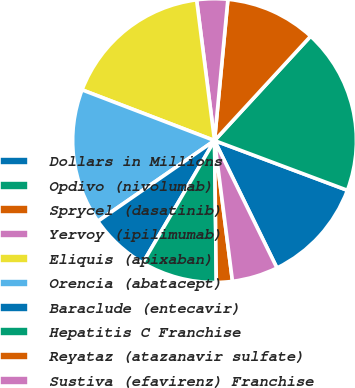Convert chart to OTSL. <chart><loc_0><loc_0><loc_500><loc_500><pie_chart><fcel>Dollars in Millions<fcel>Opdivo (nivolumab)<fcel>Sprycel (dasatinib)<fcel>Yervoy (ipilimumab)<fcel>Eliquis (apixaban)<fcel>Orencia (abatacept)<fcel>Baraclude (entecavir)<fcel>Hepatitis C Franchise<fcel>Reyataz (atazanavir sulfate)<fcel>Sustiva (efavirenz) Franchise<nl><fcel>12.05%<fcel>18.86%<fcel>10.34%<fcel>3.52%<fcel>17.16%<fcel>15.45%<fcel>6.93%<fcel>8.64%<fcel>1.82%<fcel>5.23%<nl></chart> 